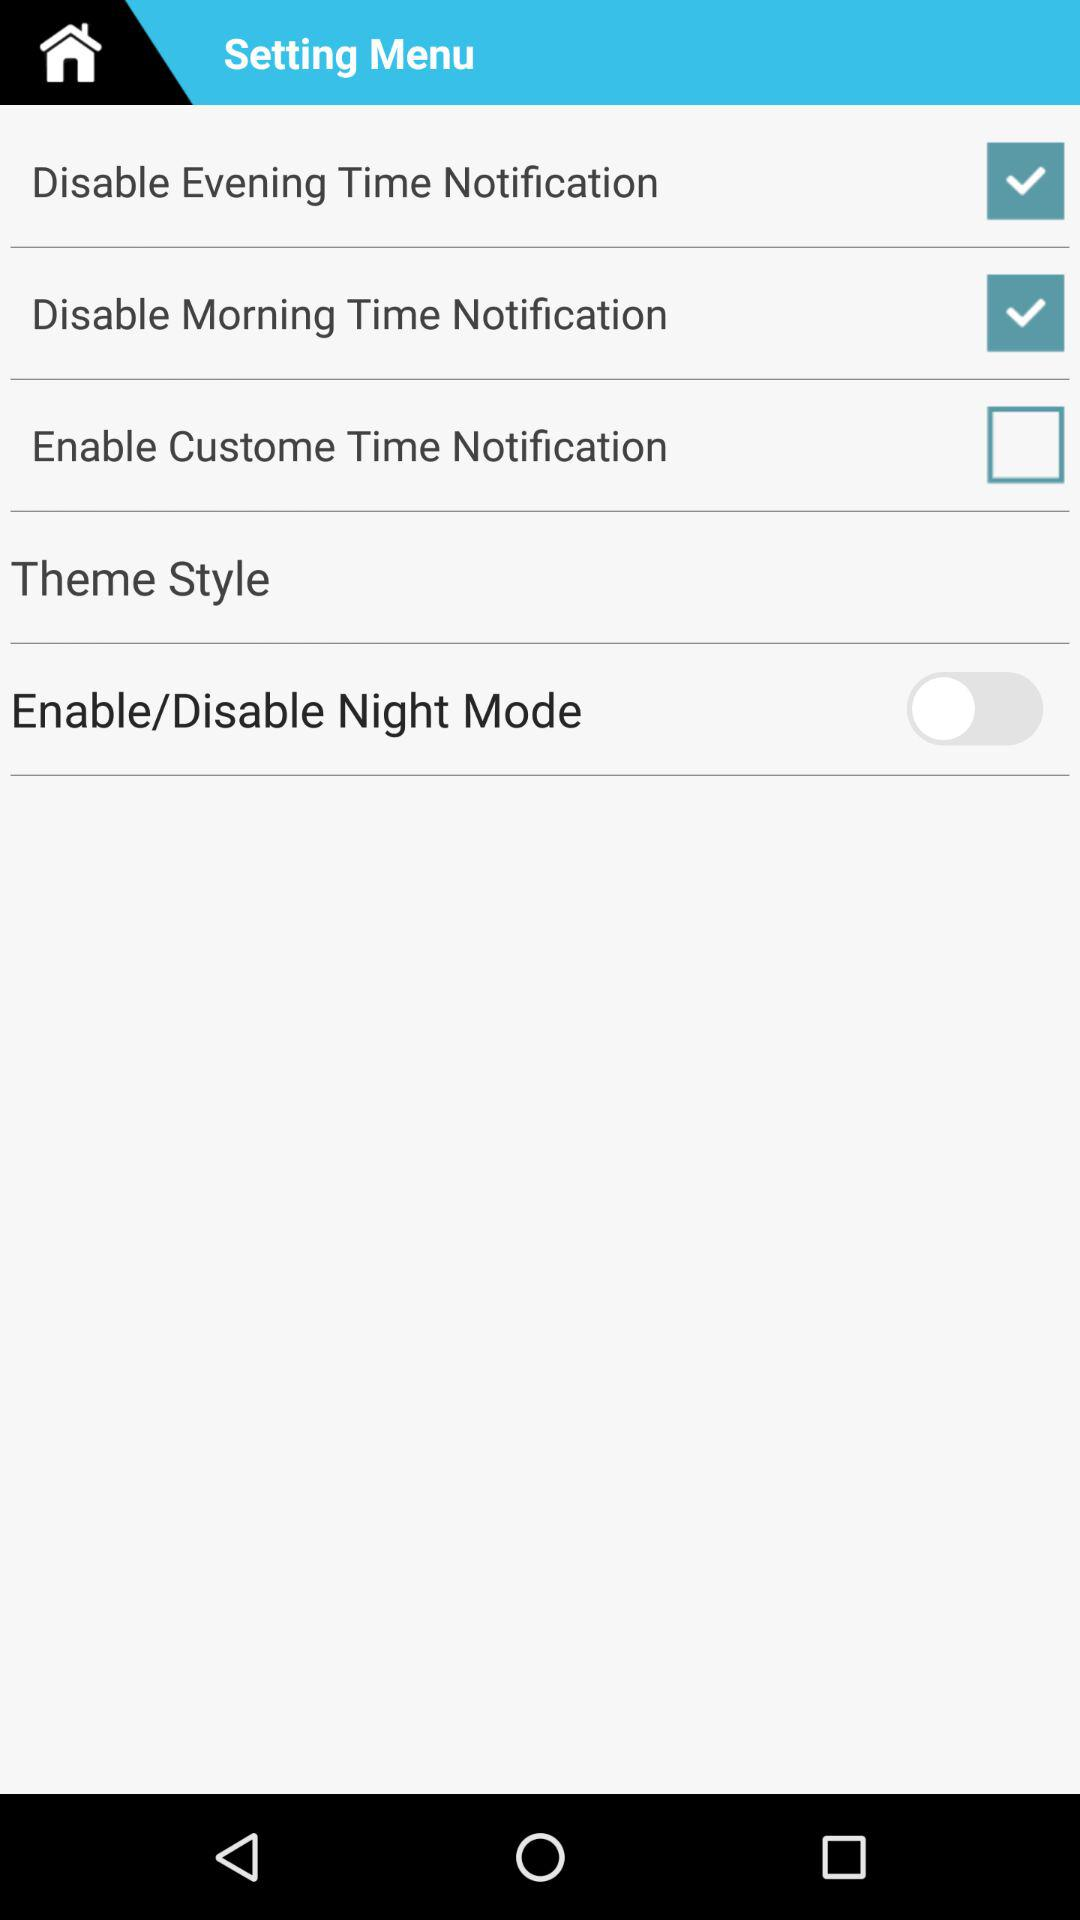What is the status of "Disable Evening Time Notification"? The status is "on". 